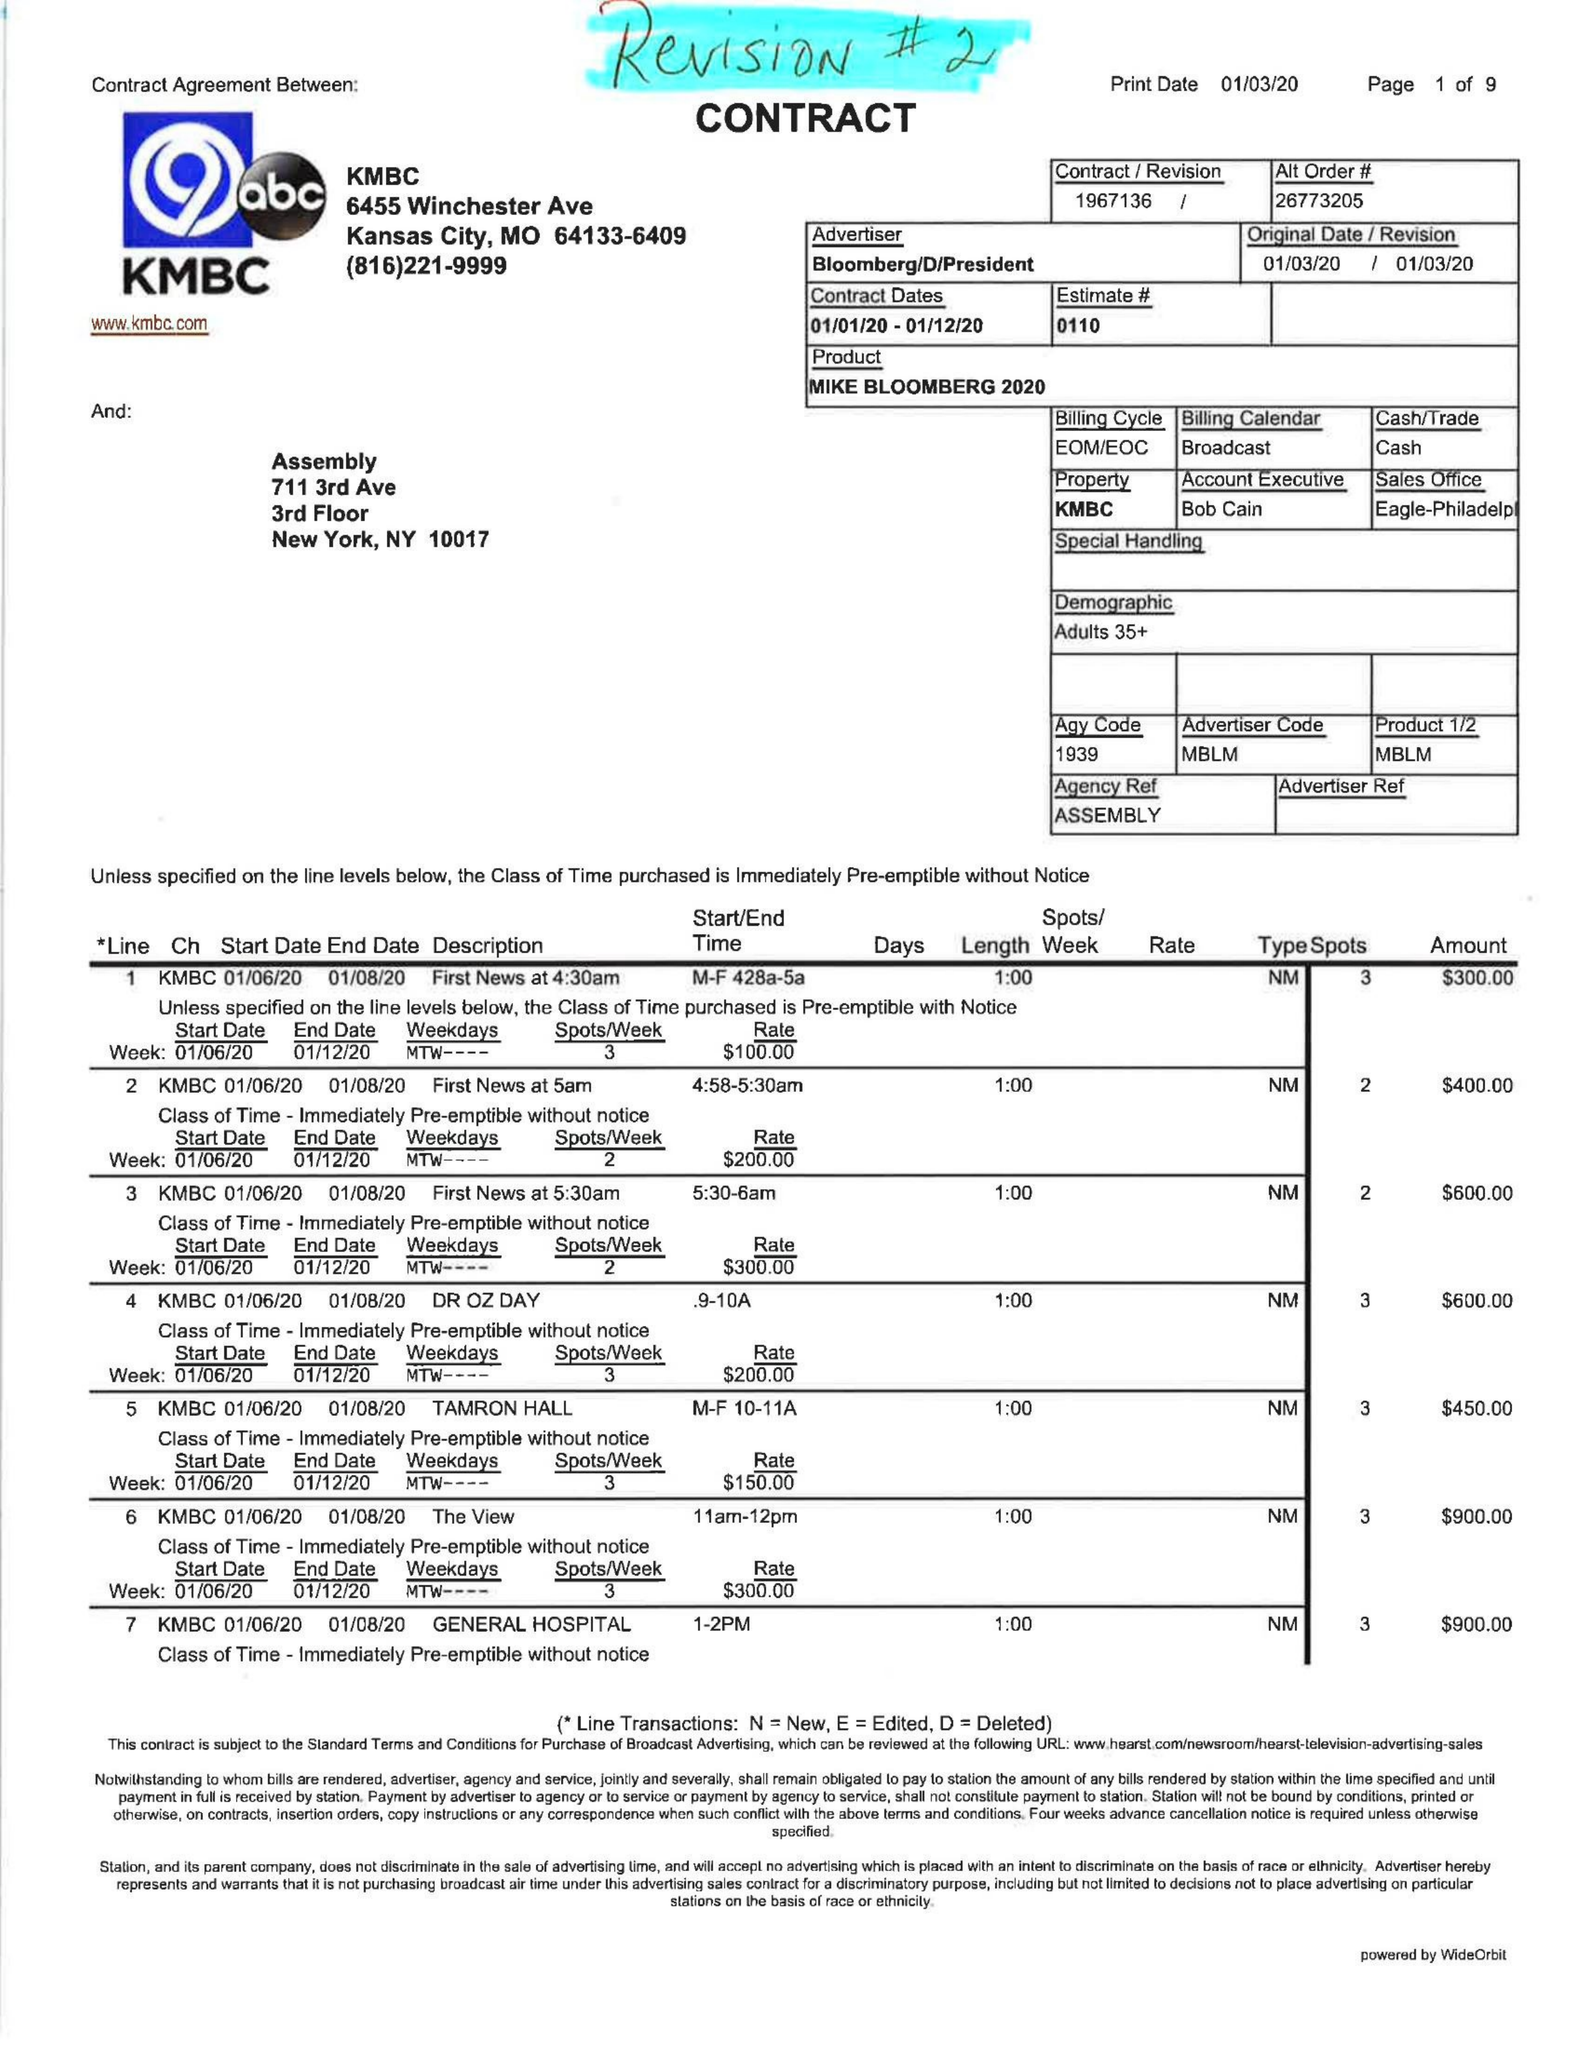What is the value for the gross_amount?
Answer the question using a single word or phrase. 49180.00 